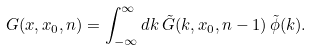Convert formula to latex. <formula><loc_0><loc_0><loc_500><loc_500>G ( x , x _ { 0 } , n ) = \int _ { - \infty } ^ { \infty } d k \, { \tilde { G } } ( k , x _ { 0 } , n - 1 ) \, { \tilde { \phi } } ( k ) .</formula> 